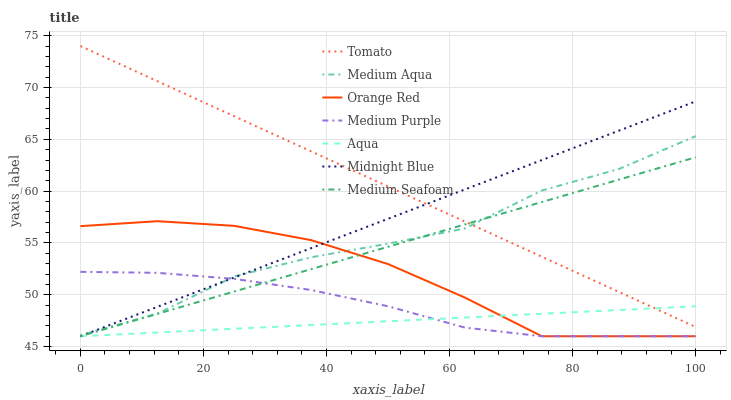Does Aqua have the minimum area under the curve?
Answer yes or no. Yes. Does Tomato have the maximum area under the curve?
Answer yes or no. Yes. Does Midnight Blue have the minimum area under the curve?
Answer yes or no. No. Does Midnight Blue have the maximum area under the curve?
Answer yes or no. No. Is Tomato the smoothest?
Answer yes or no. Yes. Is Medium Aqua the roughest?
Answer yes or no. Yes. Is Midnight Blue the smoothest?
Answer yes or no. No. Is Midnight Blue the roughest?
Answer yes or no. No. Does Midnight Blue have the lowest value?
Answer yes or no. Yes. Does Medium Aqua have the lowest value?
Answer yes or no. No. Does Tomato have the highest value?
Answer yes or no. Yes. Does Midnight Blue have the highest value?
Answer yes or no. No. Is Medium Purple less than Tomato?
Answer yes or no. Yes. Is Tomato greater than Medium Purple?
Answer yes or no. Yes. Does Medium Aqua intersect Tomato?
Answer yes or no. Yes. Is Medium Aqua less than Tomato?
Answer yes or no. No. Is Medium Aqua greater than Tomato?
Answer yes or no. No. Does Medium Purple intersect Tomato?
Answer yes or no. No. 